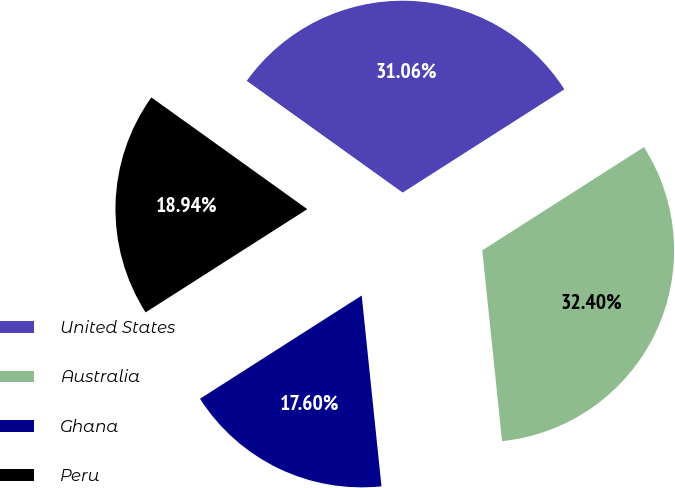<chart> <loc_0><loc_0><loc_500><loc_500><pie_chart><fcel>United States<fcel>Australia<fcel>Ghana<fcel>Peru<nl><fcel>31.06%<fcel>32.4%<fcel>17.6%<fcel>18.94%<nl></chart> 